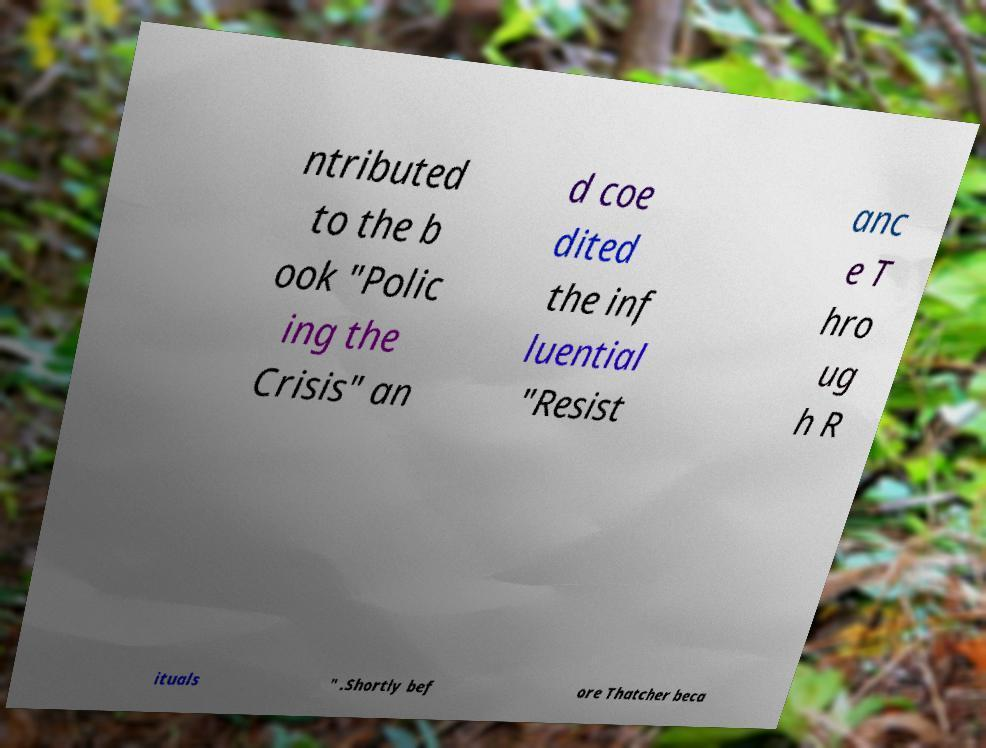Please read and relay the text visible in this image. What does it say? ntributed to the b ook "Polic ing the Crisis" an d coe dited the inf luential "Resist anc e T hro ug h R ituals " .Shortly bef ore Thatcher beca 